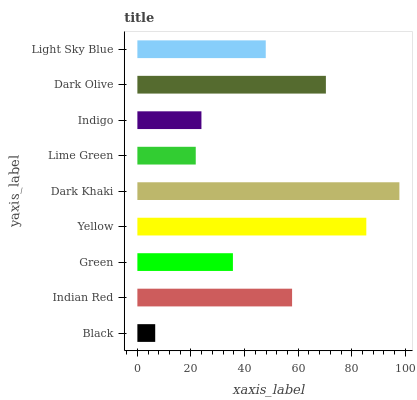Is Black the minimum?
Answer yes or no. Yes. Is Dark Khaki the maximum?
Answer yes or no. Yes. Is Indian Red the minimum?
Answer yes or no. No. Is Indian Red the maximum?
Answer yes or no. No. Is Indian Red greater than Black?
Answer yes or no. Yes. Is Black less than Indian Red?
Answer yes or no. Yes. Is Black greater than Indian Red?
Answer yes or no. No. Is Indian Red less than Black?
Answer yes or no. No. Is Light Sky Blue the high median?
Answer yes or no. Yes. Is Light Sky Blue the low median?
Answer yes or no. Yes. Is Indigo the high median?
Answer yes or no. No. Is Dark Olive the low median?
Answer yes or no. No. 